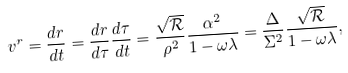<formula> <loc_0><loc_0><loc_500><loc_500>v ^ { r } = \frac { d r } { d t } = \frac { d r } { d \tau } \frac { d \tau } { d t } = \frac { \sqrt { \mathcal { R } } } { \rho ^ { 2 } } \frac { \alpha ^ { 2 } } { 1 - \omega \lambda } = \frac { \Delta } { \Sigma ^ { 2 } } \frac { \sqrt { \mathcal { R } } } { 1 - \omega \lambda } ,</formula> 